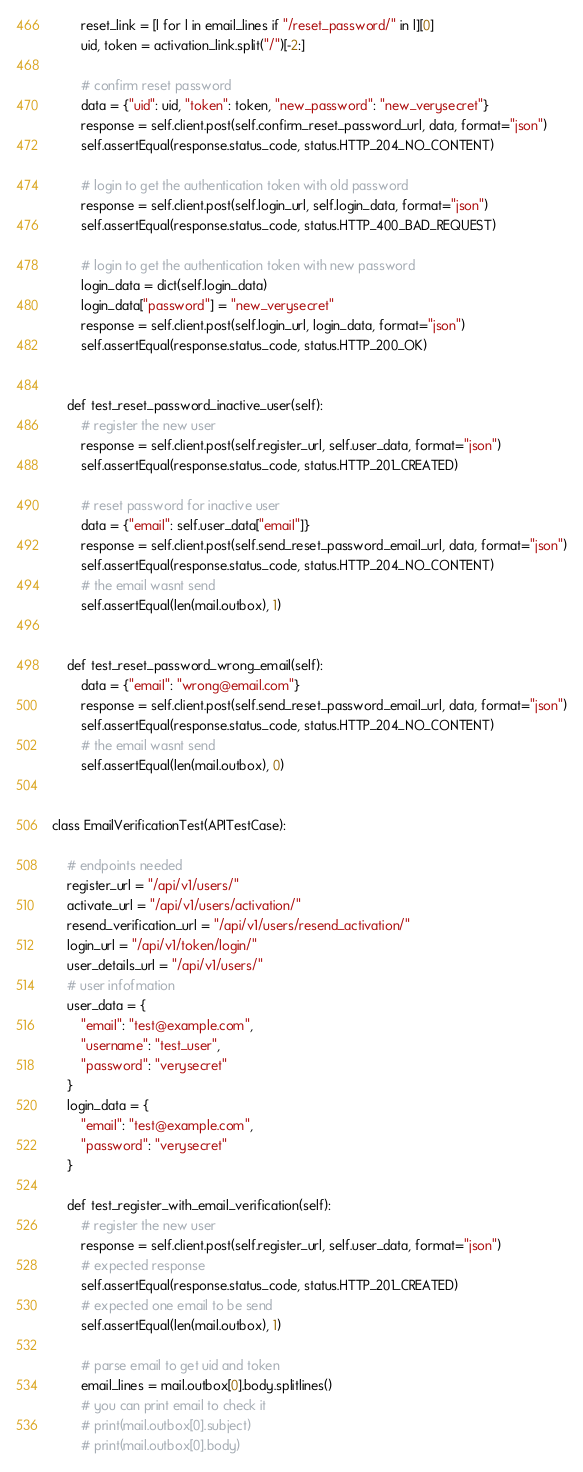<code> <loc_0><loc_0><loc_500><loc_500><_Python_>        reset_link = [l for l in email_lines if "/reset_password/" in l][0]
        uid, token = activation_link.split("/")[-2:]

        # confirm reset password
        data = {"uid": uid, "token": token, "new_password": "new_verysecret"}
        response = self.client.post(self.confirm_reset_password_url, data, format="json")
        self.assertEqual(response.status_code, status.HTTP_204_NO_CONTENT)

        # login to get the authentication token with old password
        response = self.client.post(self.login_url, self.login_data, format="json")
        self.assertEqual(response.status_code, status.HTTP_400_BAD_REQUEST)
        
        # login to get the authentication token with new password
        login_data = dict(self.login_data)
        login_data["password"] = "new_verysecret"
        response = self.client.post(self.login_url, login_data, format="json")
        self.assertEqual(response.status_code, status.HTTP_200_OK)
        

    def test_reset_password_inactive_user(self):
        # register the new user
        response = self.client.post(self.register_url, self.user_data, format="json")
        self.assertEqual(response.status_code, status.HTTP_201_CREATED)

        # reset password for inactive user
        data = {"email": self.user_data["email"]}
        response = self.client.post(self.send_reset_password_email_url, data, format="json")
        self.assertEqual(response.status_code, status.HTTP_204_NO_CONTENT)
        # the email wasnt send
        self.assertEqual(len(mail.outbox), 1)
        

    def test_reset_password_wrong_email(self):
        data = {"email": "wrong@email.com"}
        response = self.client.post(self.send_reset_password_email_url, data, format="json")
        self.assertEqual(response.status_code, status.HTTP_204_NO_CONTENT)
        # the email wasnt send
        self.assertEqual(len(mail.outbox), 0)


class EmailVerificationTest(APITestCase):

    # endpoints needed
    register_url = "/api/v1/users/"
    activate_url = "/api/v1/users/activation/"
    resend_verification_url = "/api/v1/users/resend_activation/"
    login_url = "/api/v1/token/login/"
    user_details_url = "/api/v1/users/"
    # user infofmation
    user_data = {
        "email": "test@example.com", 
        "username": "test_user", 
        "password": "verysecret"
    }
    login_data = {
        "email": "test@example.com", 
        "password": "verysecret"
    }

    def test_register_with_email_verification(self):
        # register the new user
        response = self.client.post(self.register_url, self.user_data, format="json")
        # expected response 
        self.assertEqual(response.status_code, status.HTTP_201_CREATED)
        # expected one email to be send
        self.assertEqual(len(mail.outbox), 1)
        
        # parse email to get uid and token
        email_lines = mail.outbox[0].body.splitlines()
        # you can print email to check it
        # print(mail.outbox[0].subject)
        # print(mail.outbox[0].body)</code> 